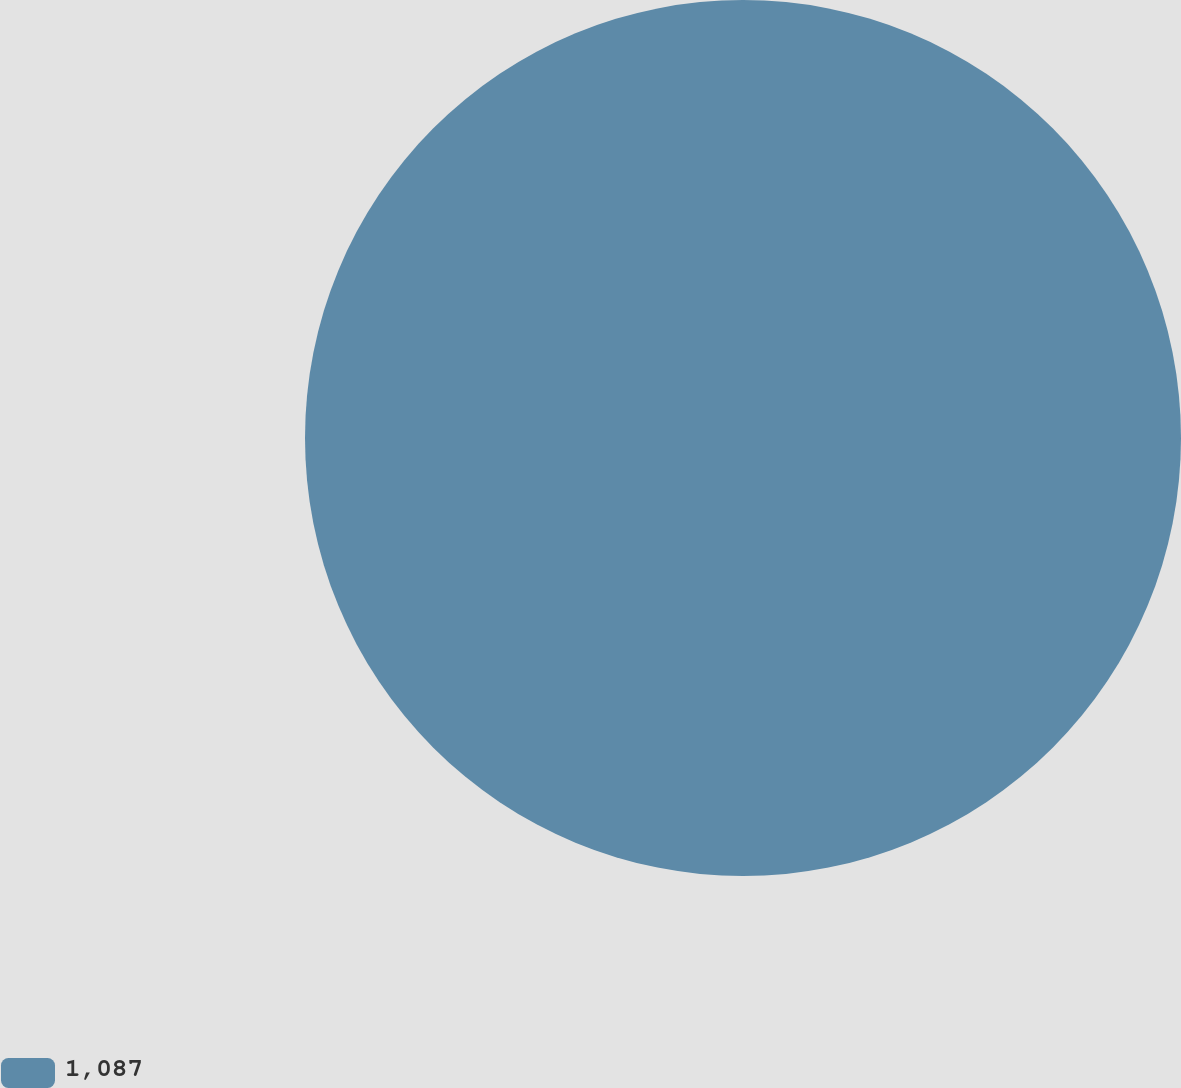Convert chart. <chart><loc_0><loc_0><loc_500><loc_500><pie_chart><fcel>1,087<nl><fcel>100.0%<nl></chart> 